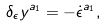<formula> <loc_0><loc_0><loc_500><loc_500>\delta _ { \epsilon } y ^ { a _ { 1 } } = - \dot { \epsilon } ^ { a _ { 1 } } ,</formula> 